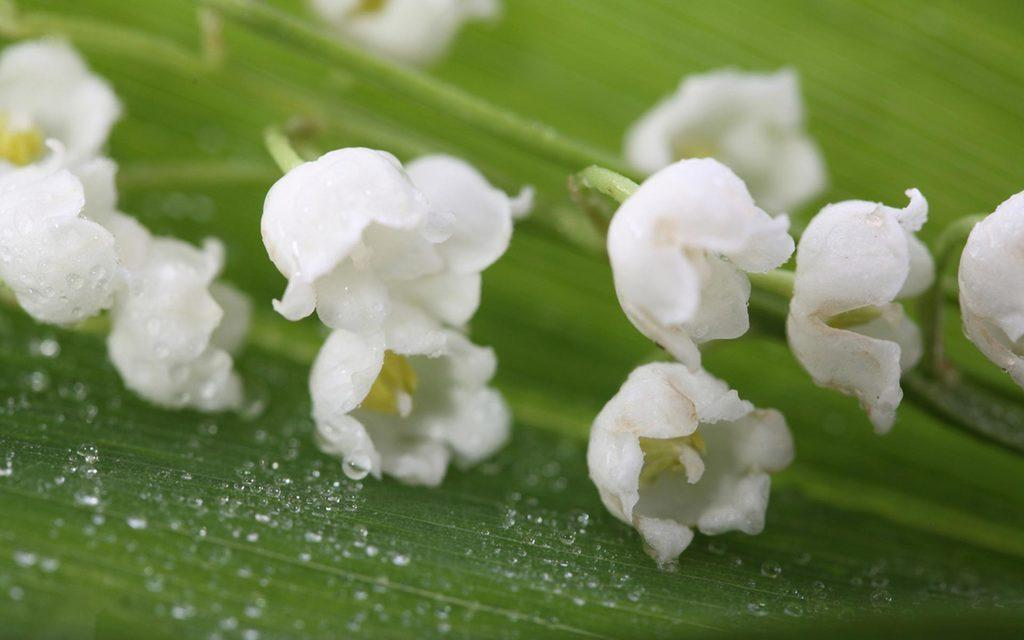What is the main subject of the image? The main subject of the image is flowers. Can you describe the flowers in the image? The flowers are located in the center of the image. How many geese are flying over the flowers in the image? There are no geese present in the image; it only features flowers. What type of watch can be seen on the flowers in the image? There is no watch present on the flowers in the image. 